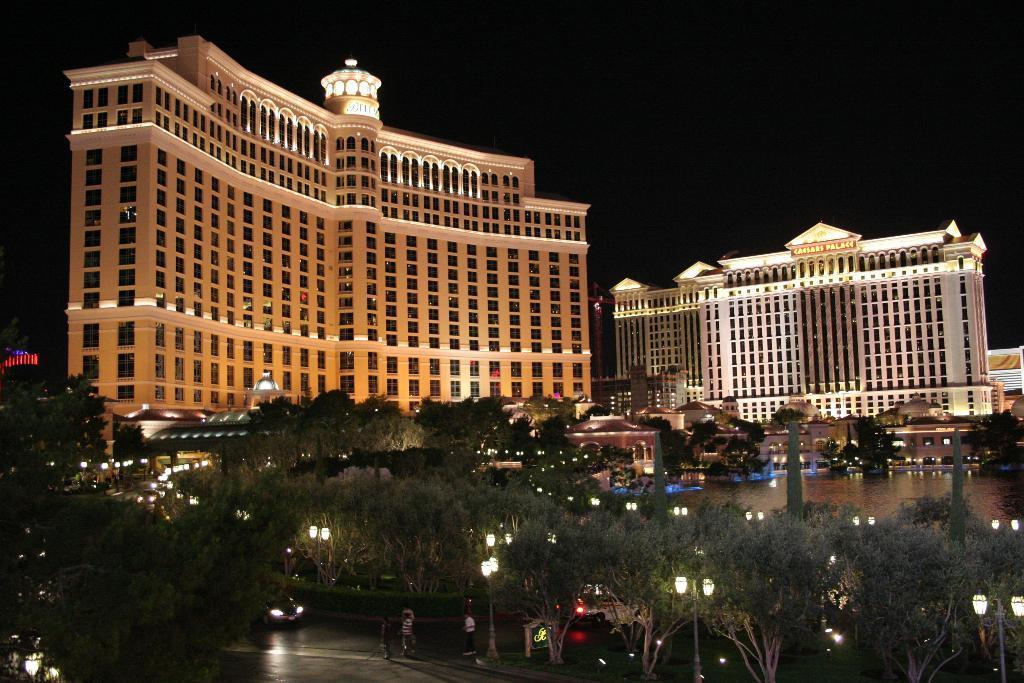In one or two sentences, can you explain what this image depicts? In this picture there are people and we can see trees, poles, lights and vehicles on the road. We can see water and buildings. In the background of the image it is dark. 